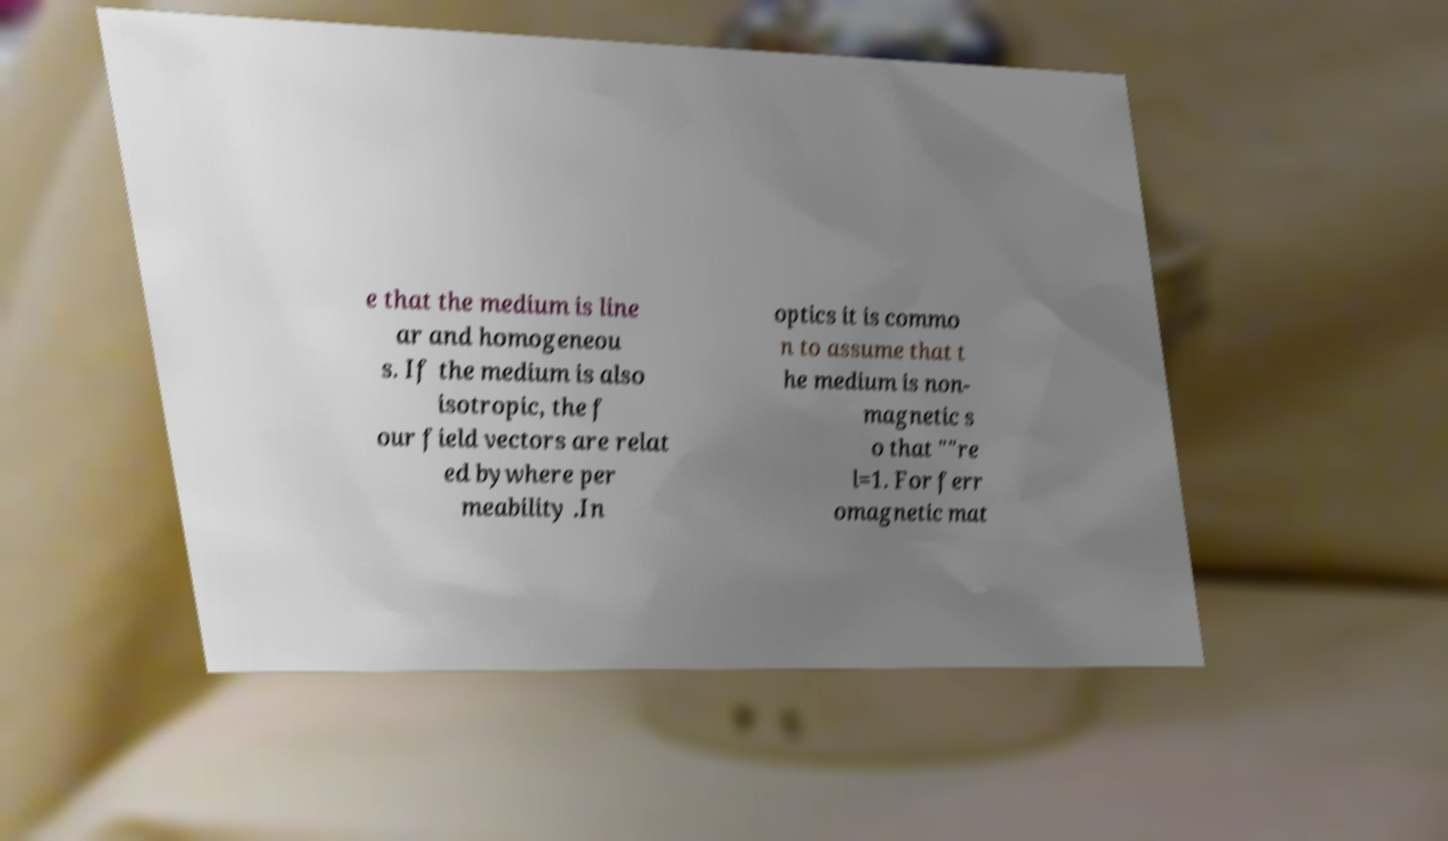Could you extract and type out the text from this image? e that the medium is line ar and homogeneou s. If the medium is also isotropic, the f our field vectors are relat ed bywhere per meability .In optics it is commo n to assume that t he medium is non- magnetic s o that ""re l=1. For ferr omagnetic mat 